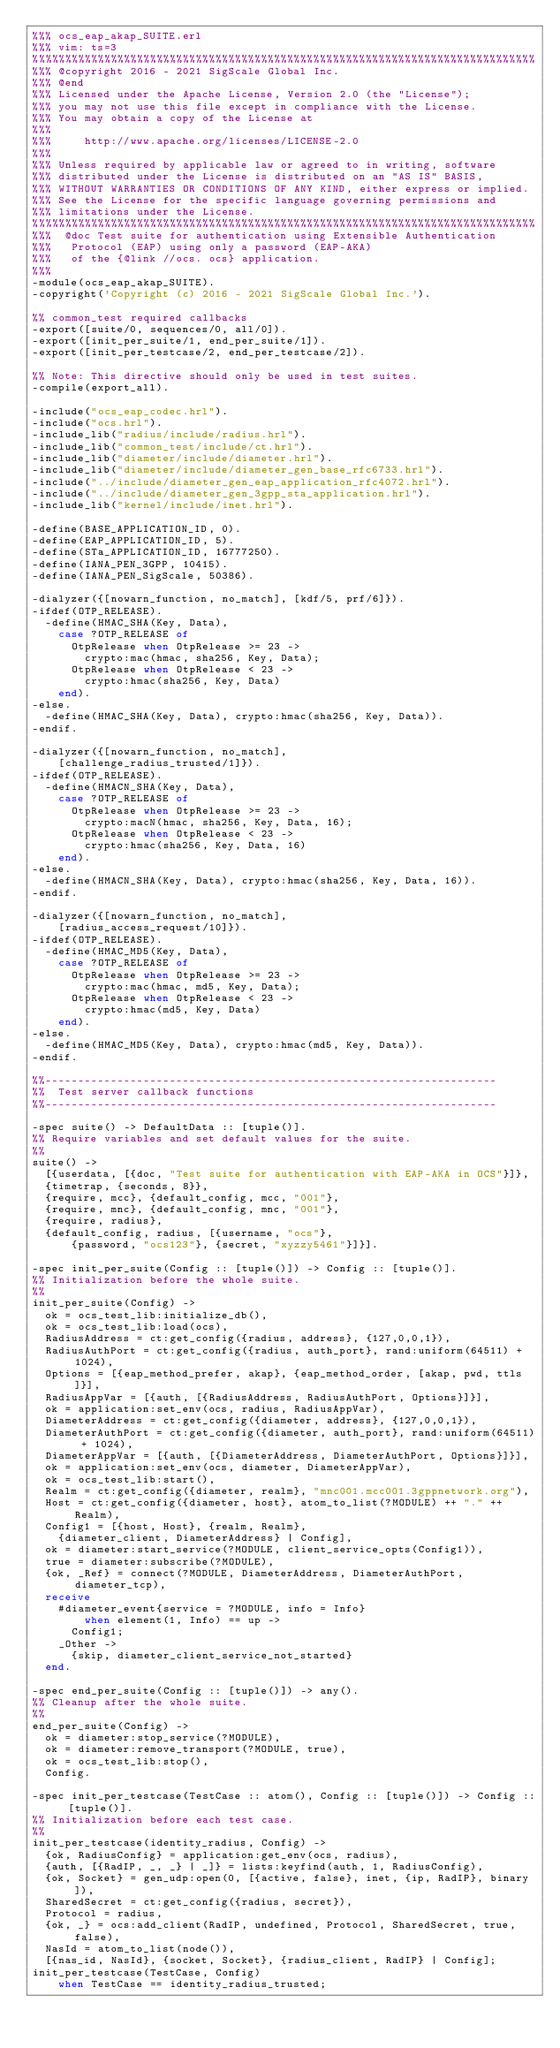<code> <loc_0><loc_0><loc_500><loc_500><_Erlang_>%%% ocs_eap_akap_SUITE.erl
%%% vim: ts=3
%%%%%%%%%%%%%%%%%%%%%%%%%%%%%%%%%%%%%%%%%%%%%%%%%%%%%%%%%%%%%%%%%%%%%%%%%%%%%
%%% @copyright 2016 - 2021 SigScale Global Inc.
%%% @end
%%% Licensed under the Apache License, Version 2.0 (the "License");
%%% you may not use this file except in compliance with the License.
%%% You may obtain a copy of the License at
%%%
%%%     http://www.apache.org/licenses/LICENSE-2.0
%%%
%%% Unless required by applicable law or agreed to in writing, software
%%% distributed under the License is distributed on an "AS IS" BASIS,
%%% WITHOUT WARRANTIES OR CONDITIONS OF ANY KIND, either express or implied.
%%% See the License for the specific language governing permissions and
%%% limitations under the License.
%%%%%%%%%%%%%%%%%%%%%%%%%%%%%%%%%%%%%%%%%%%%%%%%%%%%%%%%%%%%%%%%%%%%%%%%%%%%%
%%%  @doc Test suite for authentication using Extensible Authentication
%%% 	Protocol (EAP) using only a password (EAP-AKA)
%%% 	of the {@link //ocs. ocs} application.
%%%
-module(ocs_eap_akap_SUITE).
-copyright('Copyright (c) 2016 - 2021 SigScale Global Inc.').

%% common_test required callbacks
-export([suite/0, sequences/0, all/0]).
-export([init_per_suite/1, end_per_suite/1]).
-export([init_per_testcase/2, end_per_testcase/2]).

%% Note: This directive should only be used in test suites.
-compile(export_all).

-include("ocs_eap_codec.hrl").
-include("ocs.hrl").
-include_lib("radius/include/radius.hrl").
-include_lib("common_test/include/ct.hrl").
-include_lib("diameter/include/diameter.hrl").
-include_lib("diameter/include/diameter_gen_base_rfc6733.hrl").
-include("../include/diameter_gen_eap_application_rfc4072.hrl").
-include("../include/diameter_gen_3gpp_sta_application.hrl").
-include_lib("kernel/include/inet.hrl").

-define(BASE_APPLICATION_ID, 0).
-define(EAP_APPLICATION_ID, 5).
-define(STa_APPLICATION_ID, 16777250).
-define(IANA_PEN_3GPP, 10415).
-define(IANA_PEN_SigScale, 50386).

-dialyzer({[nowarn_function, no_match], [kdf/5, prf/6]}).
-ifdef(OTP_RELEASE).
	-define(HMAC_SHA(Key, Data),
		case ?OTP_RELEASE of
			OtpRelease when OtpRelease >= 23 ->
				crypto:mac(hmac, sha256, Key, Data);
			OtpRelease when OtpRelease < 23 ->
				crypto:hmac(sha256, Key, Data)
		end).
-else.
	-define(HMAC_SHA(Key, Data), crypto:hmac(sha256, Key, Data)).
-endif.

-dialyzer({[nowarn_function, no_match],
		[challenge_radius_trusted/1]}).
-ifdef(OTP_RELEASE).
	-define(HMACN_SHA(Key, Data),
		case ?OTP_RELEASE of
			OtpRelease when OtpRelease >= 23 ->
				crypto:macN(hmac, sha256, Key, Data, 16);
			OtpRelease when OtpRelease < 23 ->
				crypto:hmac(sha256, Key, Data, 16)
		end).
-else.
	-define(HMACN_SHA(Key, Data), crypto:hmac(sha256, Key, Data, 16)).
-endif.

-dialyzer({[nowarn_function, no_match],
		[radius_access_request/10]}).
-ifdef(OTP_RELEASE).
	-define(HMAC_MD5(Key, Data),
		case ?OTP_RELEASE of
			OtpRelease when OtpRelease >= 23 ->
				crypto:mac(hmac, md5, Key, Data);
			OtpRelease when OtpRelease < 23 ->
				crypto:hmac(md5, Key, Data)
		end).
-else.
	-define(HMAC_MD5(Key, Data), crypto:hmac(md5, Key, Data)).
-endif.

%%---------------------------------------------------------------------
%%  Test server callback functions
%%---------------------------------------------------------------------

-spec suite() -> DefaultData :: [tuple()].
%% Require variables and set default values for the suite.
%%
suite() ->
	[{userdata, [{doc, "Test suite for authentication with EAP-AKA in OCS"}]},
	{timetrap, {seconds, 8}},
	{require, mcc}, {default_config, mcc, "001"},
	{require, mnc}, {default_config, mnc, "001"},
	{require, radius},
	{default_config, radius, [{username, "ocs"},
			{password, "ocs123"}, {secret, "xyzzy5461"}]}].

-spec init_per_suite(Config :: [tuple()]) -> Config :: [tuple()].
%% Initialization before the whole suite.
%%
init_per_suite(Config) ->
	ok = ocs_test_lib:initialize_db(),
	ok = ocs_test_lib:load(ocs),
	RadiusAddress = ct:get_config({radius, address}, {127,0,0,1}),
	RadiusAuthPort = ct:get_config({radius, auth_port}, rand:uniform(64511) + 1024),
	Options = [{eap_method_prefer, akap}, {eap_method_order, [akap, pwd, ttls]}],
	RadiusAppVar = [{auth, [{RadiusAddress, RadiusAuthPort, Options}]}],
	ok = application:set_env(ocs, radius, RadiusAppVar),
	DiameterAddress = ct:get_config({diameter, address}, {127,0,0,1}),
	DiameterAuthPort = ct:get_config({diameter, auth_port}, rand:uniform(64511) + 1024),
	DiameterAppVar = [{auth, [{DiameterAddress, DiameterAuthPort, Options}]}],
	ok = application:set_env(ocs, diameter, DiameterAppVar),
	ok = ocs_test_lib:start(),
	Realm = ct:get_config({diameter, realm}, "mnc001.mcc001.3gppnetwork.org"),
	Host = ct:get_config({diameter, host}, atom_to_list(?MODULE) ++ "." ++ Realm),
	Config1 = [{host, Host}, {realm, Realm},
		{diameter_client, DiameterAddress} | Config],
	ok = diameter:start_service(?MODULE, client_service_opts(Config1)),
	true = diameter:subscribe(?MODULE),
	{ok, _Ref} = connect(?MODULE, DiameterAddress, DiameterAuthPort, diameter_tcp),
	receive
		#diameter_event{service = ?MODULE, info = Info}
				when element(1, Info) == up ->
			Config1;
		_Other ->
			{skip, diameter_client_service_not_started}
	end.

-spec end_per_suite(Config :: [tuple()]) -> any().
%% Cleanup after the whole suite.
%%
end_per_suite(Config) ->
	ok = diameter:stop_service(?MODULE),
	ok = diameter:remove_transport(?MODULE, true),
	ok = ocs_test_lib:stop(),
	Config.

-spec init_per_testcase(TestCase :: atom(), Config :: [tuple()]) -> Config :: [tuple()].
%% Initialization before each test case.
%%
init_per_testcase(identity_radius, Config) ->
	{ok, RadiusConfig} = application:get_env(ocs, radius),
	{auth, [{RadIP, _, _} | _]} = lists:keyfind(auth, 1, RadiusConfig),
	{ok, Socket} = gen_udp:open(0, [{active, false}, inet, {ip, RadIP}, binary]),
	SharedSecret = ct:get_config({radius, secret}),
	Protocol = radius,
	{ok, _} = ocs:add_client(RadIP, undefined, Protocol, SharedSecret, true, false),
	NasId = atom_to_list(node()),
	[{nas_id, NasId}, {socket, Socket}, {radius_client, RadIP} | Config];
init_per_testcase(TestCase, Config)
		when TestCase == identity_radius_trusted;</code> 